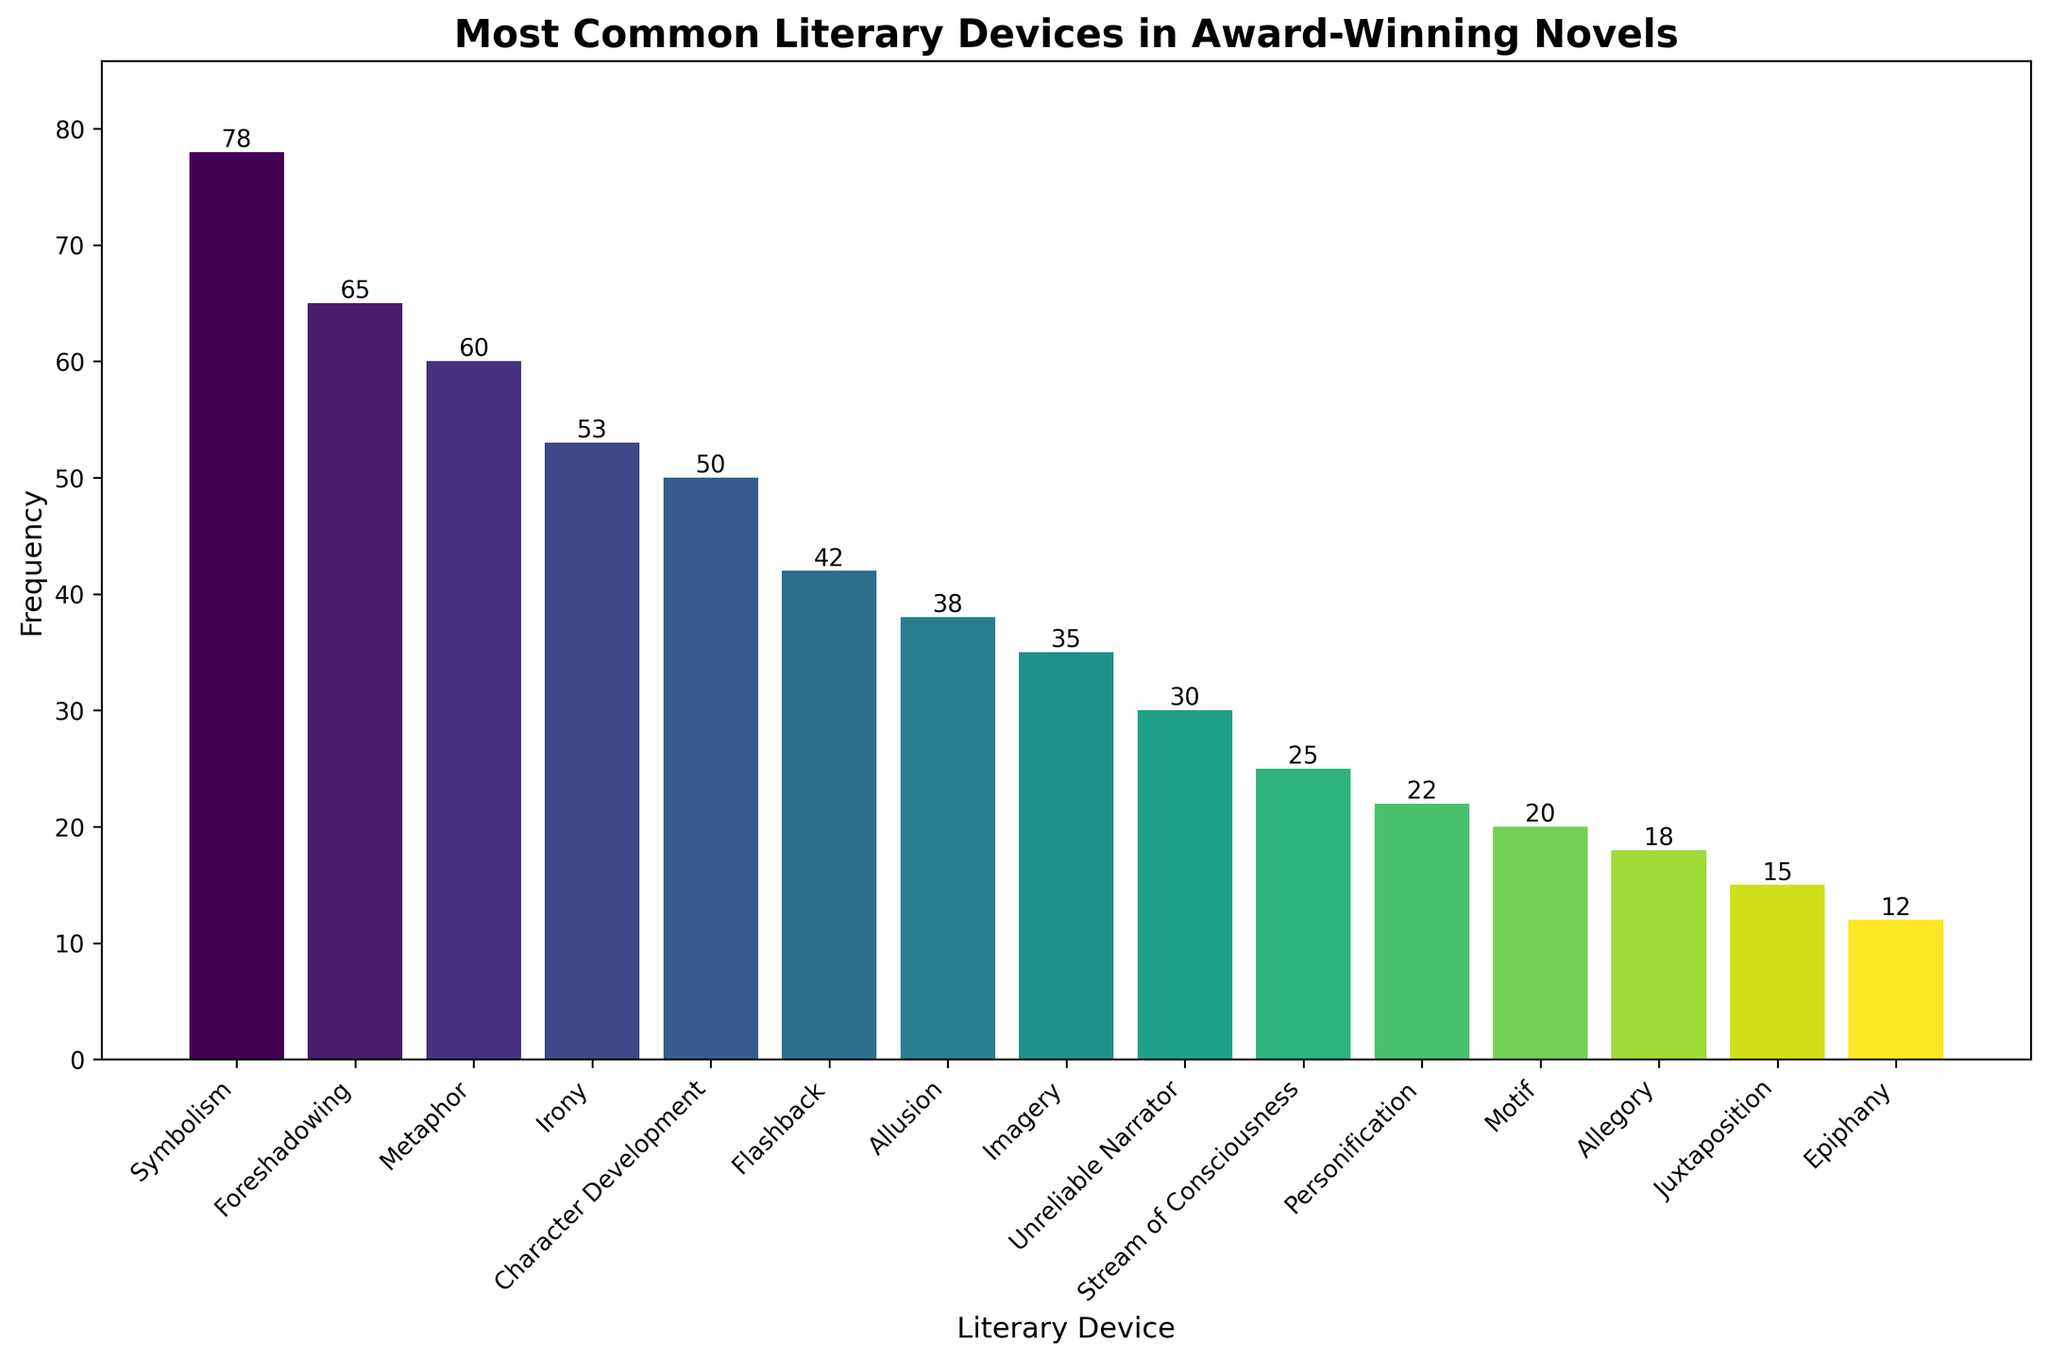Which literary device is used the most frequently? By observing the heights of the bars, the tallest bar represents 'Symbolism' with a frequency of 78.
Answer: Symbolism Which two literary devices have the closest frequencies? By comparing the bar heights visually, 'Character Development' (50) and 'Flashback' (42) have frequencies closer to each other.
Answer: Character Development and Flashback How many literary devices have a frequency of less than 30? By checking the heights of the bars that are below the 30 mark on the y-axis, 'Unreliable Narrator', 'Stream of Consciousness', 'Personification', 'Motif', 'Allegory', 'Juxtaposition', and 'Epiphany' are counted, making it 7 devices.
Answer: 7 Which literary device is used more, 'Irony' or 'Imagery'? By comparing the heights of the 'Irony' and 'Imagery' bars, 'Irony' is higher with a frequency of 53, while 'Imagery' has a frequency of 35.
Answer: Irony What is the combined frequency of the three least commonly used literary devices? The three shortest bars represent 'Juxtaposition' (15), 'Epiphany' (12), and 'Allegory' (18). Adding these frequencies results in 15 + 12 + 18 = 45.
Answer: 45 Which literary device appears exactly in the middle of the frequency distribution? Arranging the devices in order of frequency, the median device is 'Character Development' with a frequency of 50.
Answer: Character Development How much more frequent is 'Symbolism' compared to 'Motif'? The frequency of 'Symbolism' is 78 and 'Motif' is 20. The difference is 78 - 20 = 58.
Answer: 58 What is the average frequency of the top five most common literary devices? The top five devices are 'Symbolism' (78), 'Foreshadowing' (65), 'Metaphor' (60), 'Irony' (53), and 'Character Development' (50). The sum is 78 + 65 + 60 + 53 + 50 = 306. The average is 306 / 5 = 61.2.
Answer: 61.2 